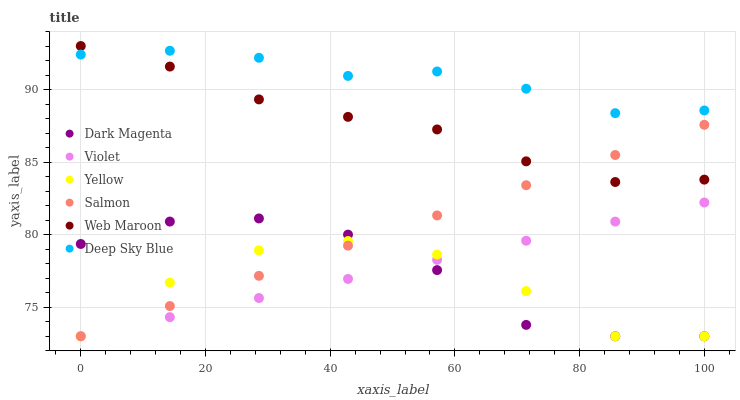Does Yellow have the minimum area under the curve?
Answer yes or no. Yes. Does Deep Sky Blue have the maximum area under the curve?
Answer yes or no. Yes. Does Salmon have the minimum area under the curve?
Answer yes or no. No. Does Salmon have the maximum area under the curve?
Answer yes or no. No. Is Violet the smoothest?
Answer yes or no. Yes. Is Yellow the roughest?
Answer yes or no. Yes. Is Salmon the smoothest?
Answer yes or no. No. Is Salmon the roughest?
Answer yes or no. No. Does Dark Magenta have the lowest value?
Answer yes or no. Yes. Does Web Maroon have the lowest value?
Answer yes or no. No. Does Web Maroon have the highest value?
Answer yes or no. Yes. Does Salmon have the highest value?
Answer yes or no. No. Is Violet less than Web Maroon?
Answer yes or no. Yes. Is Deep Sky Blue greater than Violet?
Answer yes or no. Yes. Does Violet intersect Dark Magenta?
Answer yes or no. Yes. Is Violet less than Dark Magenta?
Answer yes or no. No. Is Violet greater than Dark Magenta?
Answer yes or no. No. Does Violet intersect Web Maroon?
Answer yes or no. No. 